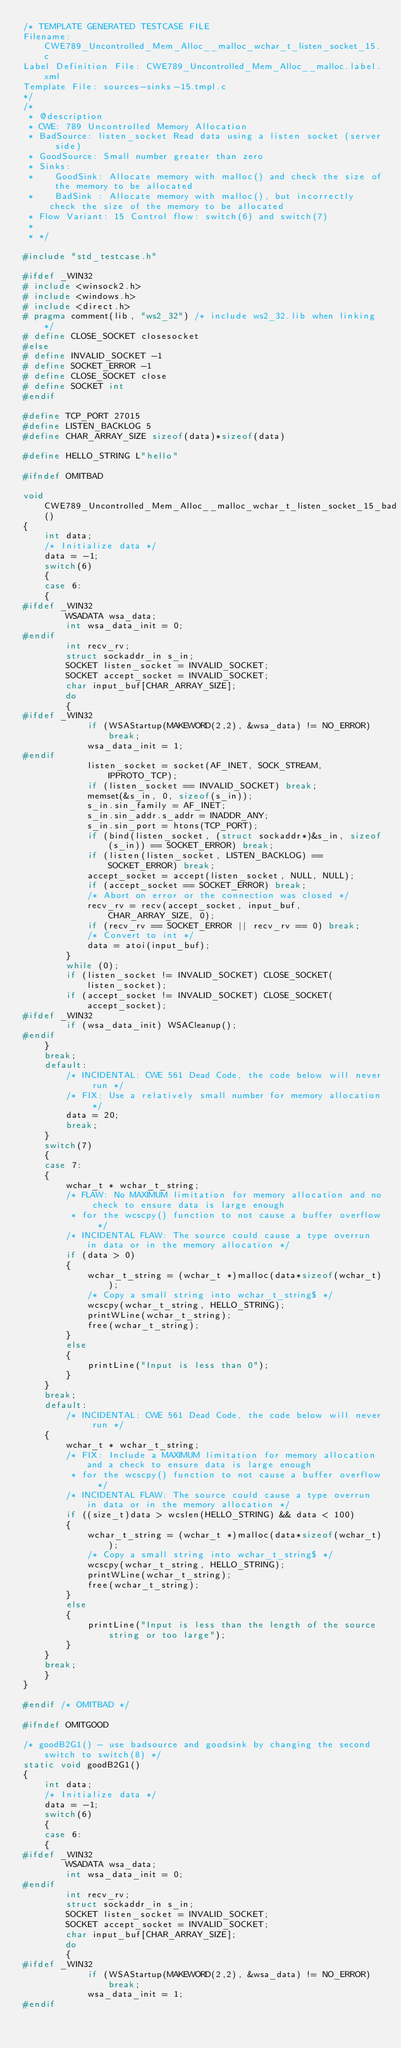Convert code to text. <code><loc_0><loc_0><loc_500><loc_500><_C_>/* TEMPLATE GENERATED TESTCASE FILE
Filename: CWE789_Uncontrolled_Mem_Alloc__malloc_wchar_t_listen_socket_15.c
Label Definition File: CWE789_Uncontrolled_Mem_Alloc__malloc.label.xml
Template File: sources-sinks-15.tmpl.c
*/
/*
 * @description
 * CWE: 789 Uncontrolled Memory Allocation
 * BadSource: listen_socket Read data using a listen socket (server side)
 * GoodSource: Small number greater than zero
 * Sinks:
 *    GoodSink: Allocate memory with malloc() and check the size of the memory to be allocated
 *    BadSink : Allocate memory with malloc(), but incorrectly check the size of the memory to be allocated
 * Flow Variant: 15 Control flow: switch(6) and switch(7)
 *
 * */

#include "std_testcase.h"

#ifdef _WIN32
# include <winsock2.h>
# include <windows.h>
# include <direct.h>
# pragma comment(lib, "ws2_32") /* include ws2_32.lib when linking */
# define CLOSE_SOCKET closesocket
#else
# define INVALID_SOCKET -1
# define SOCKET_ERROR -1
# define CLOSE_SOCKET close
# define SOCKET int
#endif

#define TCP_PORT 27015
#define LISTEN_BACKLOG 5
#define CHAR_ARRAY_SIZE sizeof(data)*sizeof(data)

#define HELLO_STRING L"hello"

#ifndef OMITBAD

void CWE789_Uncontrolled_Mem_Alloc__malloc_wchar_t_listen_socket_15_bad()
{
    int data;
    /* Initialize data */
    data = -1;
    switch(6)
    {
    case 6:
    {
#ifdef _WIN32
        WSADATA wsa_data;
        int wsa_data_init = 0;
#endif
        int recv_rv;
        struct sockaddr_in s_in;
        SOCKET listen_socket = INVALID_SOCKET;
        SOCKET accept_socket = INVALID_SOCKET;
        char input_buf[CHAR_ARRAY_SIZE];
        do
        {
#ifdef _WIN32
            if (WSAStartup(MAKEWORD(2,2), &wsa_data) != NO_ERROR) break;
            wsa_data_init = 1;
#endif
            listen_socket = socket(AF_INET, SOCK_STREAM, IPPROTO_TCP);
            if (listen_socket == INVALID_SOCKET) break;
            memset(&s_in, 0, sizeof(s_in));
            s_in.sin_family = AF_INET;
            s_in.sin_addr.s_addr = INADDR_ANY;
            s_in.sin_port = htons(TCP_PORT);
            if (bind(listen_socket, (struct sockaddr*)&s_in, sizeof(s_in)) == SOCKET_ERROR) break;
            if (listen(listen_socket, LISTEN_BACKLOG) == SOCKET_ERROR) break;
            accept_socket = accept(listen_socket, NULL, NULL);
            if (accept_socket == SOCKET_ERROR) break;
            /* Abort on error or the connection was closed */
            recv_rv = recv(accept_socket, input_buf, CHAR_ARRAY_SIZE, 0);
            if (recv_rv == SOCKET_ERROR || recv_rv == 0) break;
            /* Convert to int */
            data = atoi(input_buf);
        }
        while (0);
        if (listen_socket != INVALID_SOCKET) CLOSE_SOCKET(listen_socket);
        if (accept_socket != INVALID_SOCKET) CLOSE_SOCKET(accept_socket);
#ifdef _WIN32
        if (wsa_data_init) WSACleanup();
#endif
    }
    break;
    default:
        /* INCIDENTAL: CWE 561 Dead Code, the code below will never run */
        /* FIX: Use a relatively small number for memory allocation */
        data = 20;
        break;
    }
    switch(7)
    {
    case 7:
    {
        wchar_t * wchar_t_string;
        /* FLAW: No MAXIMUM limitation for memory allocation and no check to ensure data is large enough
         * for the wcscpy() function to not cause a buffer overflow */
        /* INCIDENTAL FLAW: The source could cause a type overrun in data or in the memory allocation */
        if (data > 0)
        {
            wchar_t_string = (wchar_t *)malloc(data*sizeof(wchar_t));
            /* Copy a small string into wchar_t_string$ */
            wcscpy(wchar_t_string, HELLO_STRING);
            printWLine(wchar_t_string);
            free(wchar_t_string);
        }
        else
        {
            printLine("Input is less than 0");
        }
    }
    break;
    default:
        /* INCIDENTAL: CWE 561 Dead Code, the code below will never run */
    {
        wchar_t * wchar_t_string;
        /* FIX: Include a MAXIMUM limitation for memory allocation and a check to ensure data is large enough
         * for the wcscpy() function to not cause a buffer overflow */
        /* INCIDENTAL FLAW: The source could cause a type overrun in data or in the memory allocation */
        if ((size_t)data > wcslen(HELLO_STRING) && data < 100)
        {
            wchar_t_string = (wchar_t *)malloc(data*sizeof(wchar_t));
            /* Copy a small string into wchar_t_string$ */
            wcscpy(wchar_t_string, HELLO_STRING);
            printWLine(wchar_t_string);
            free(wchar_t_string);
        }
        else
        {
            printLine("Input is less than the length of the source string or too large");
        }
    }
    break;
    }
}

#endif /* OMITBAD */

#ifndef OMITGOOD

/* goodB2G1() - use badsource and goodsink by changing the second switch to switch(8) */
static void goodB2G1()
{
    int data;
    /* Initialize data */
    data = -1;
    switch(6)
    {
    case 6:
    {
#ifdef _WIN32
        WSADATA wsa_data;
        int wsa_data_init = 0;
#endif
        int recv_rv;
        struct sockaddr_in s_in;
        SOCKET listen_socket = INVALID_SOCKET;
        SOCKET accept_socket = INVALID_SOCKET;
        char input_buf[CHAR_ARRAY_SIZE];
        do
        {
#ifdef _WIN32
            if (WSAStartup(MAKEWORD(2,2), &wsa_data) != NO_ERROR) break;
            wsa_data_init = 1;
#endif</code> 